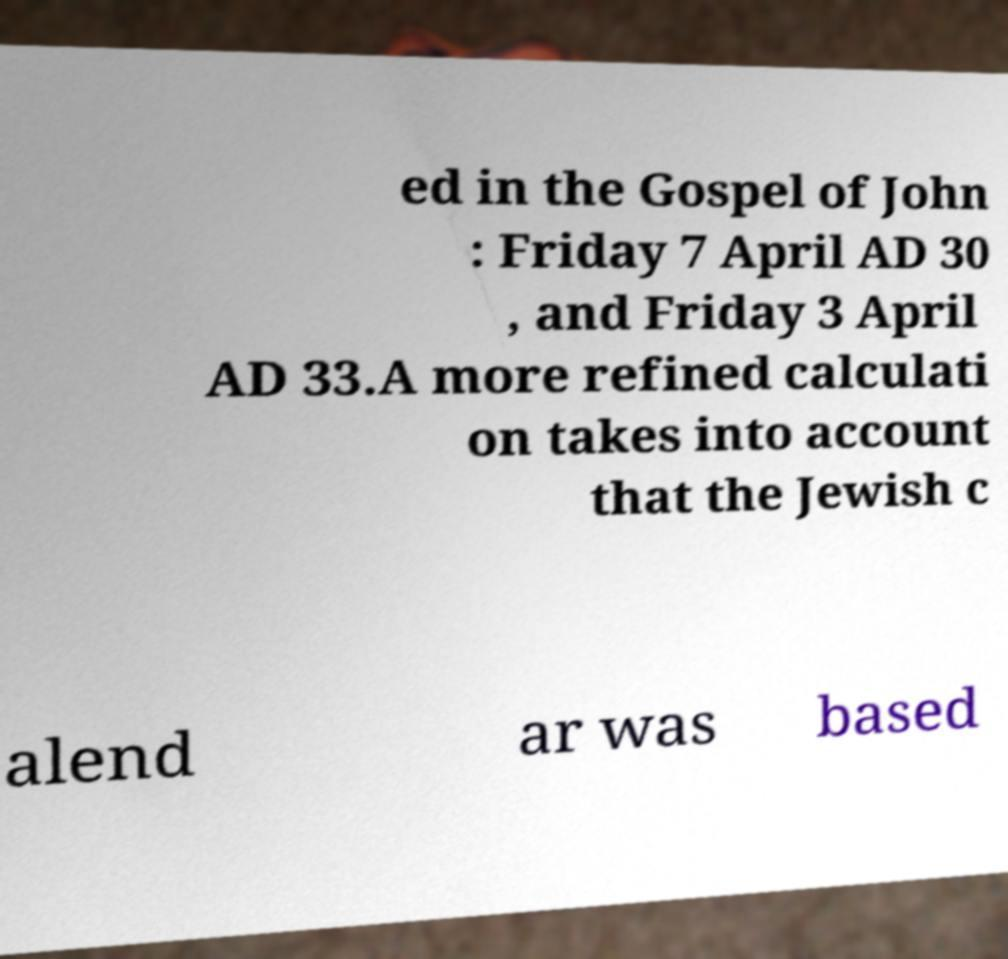Could you assist in decoding the text presented in this image and type it out clearly? ed in the Gospel of John : Friday 7 April AD 30 , and Friday 3 April AD 33.A more refined calculati on takes into account that the Jewish c alend ar was based 